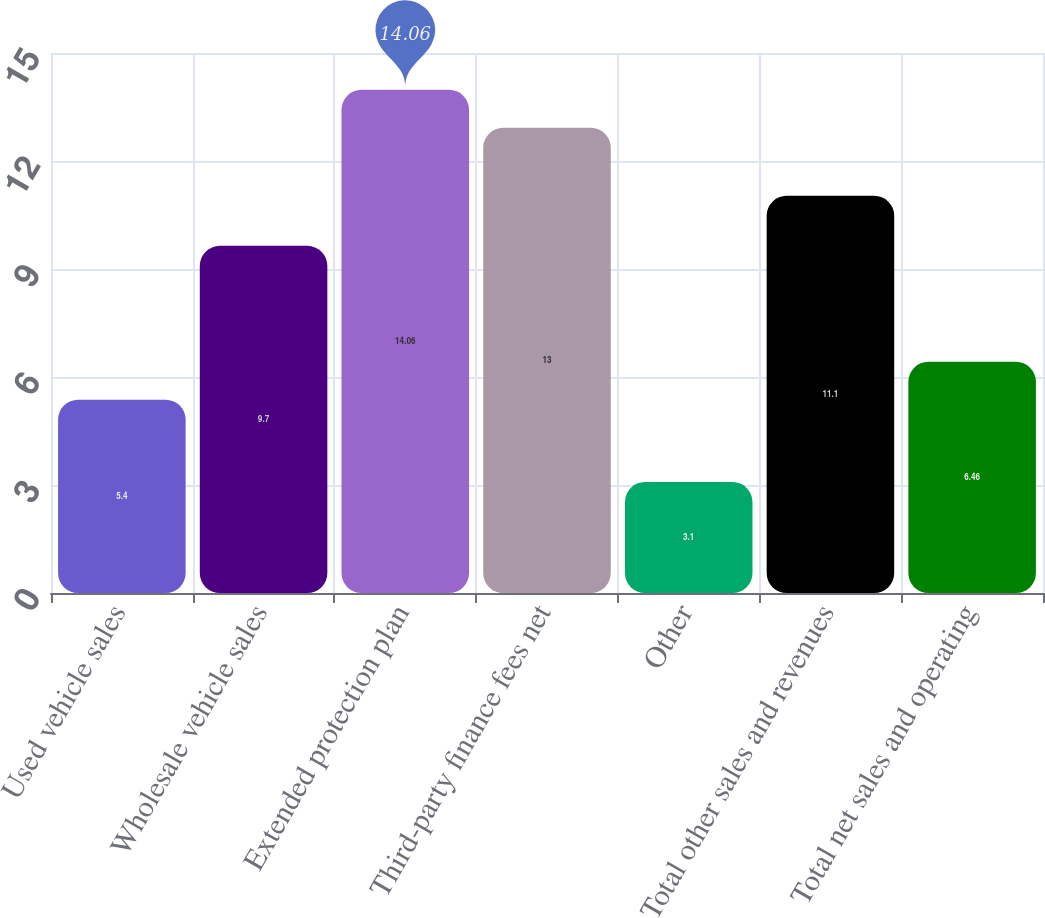Convert chart. <chart><loc_0><loc_0><loc_500><loc_500><bar_chart><fcel>Used vehicle sales<fcel>Wholesale vehicle sales<fcel>Extended protection plan<fcel>Third-party finance fees net<fcel>Other<fcel>Total other sales and revenues<fcel>Total net sales and operating<nl><fcel>5.4<fcel>9.7<fcel>14.06<fcel>13<fcel>3.1<fcel>11.1<fcel>6.46<nl></chart> 